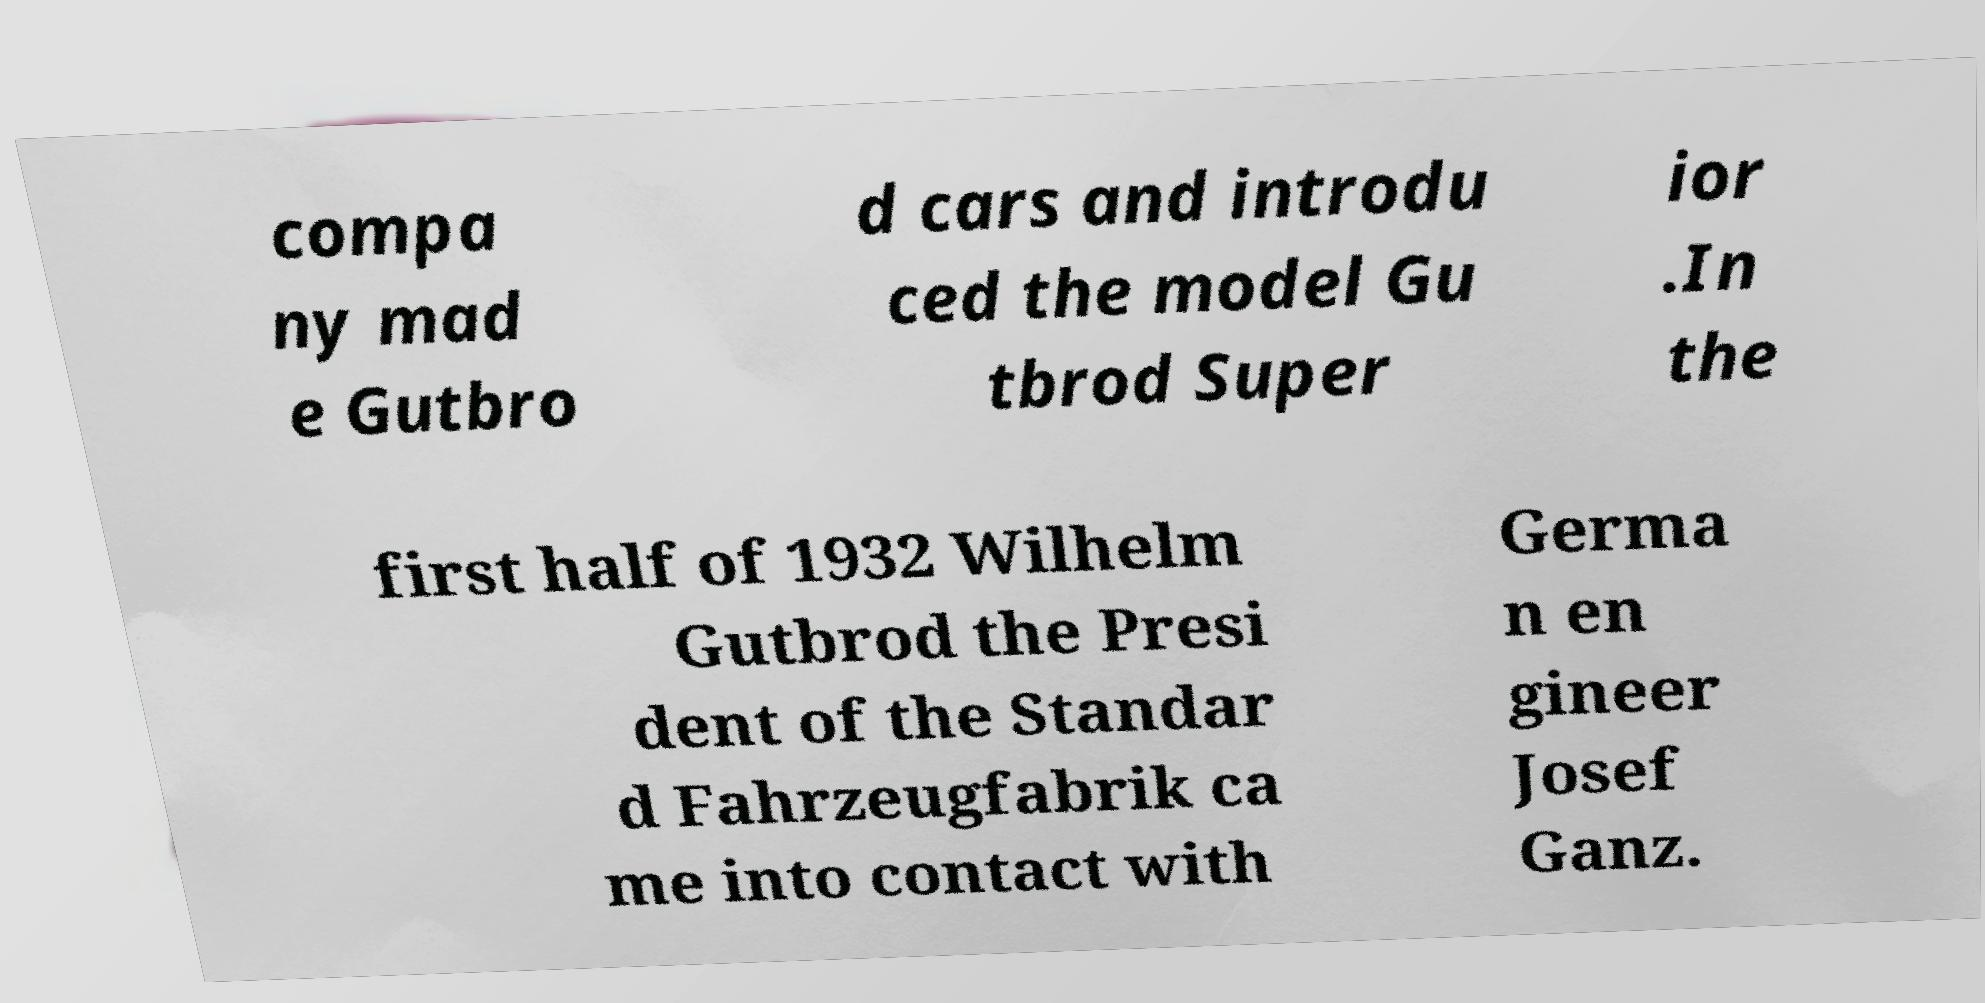Can you accurately transcribe the text from the provided image for me? compa ny mad e Gutbro d cars and introdu ced the model Gu tbrod Super ior .In the first half of 1932 Wilhelm Gutbrod the Presi dent of the Standar d Fahrzeugfabrik ca me into contact with Germa n en gineer Josef Ganz. 